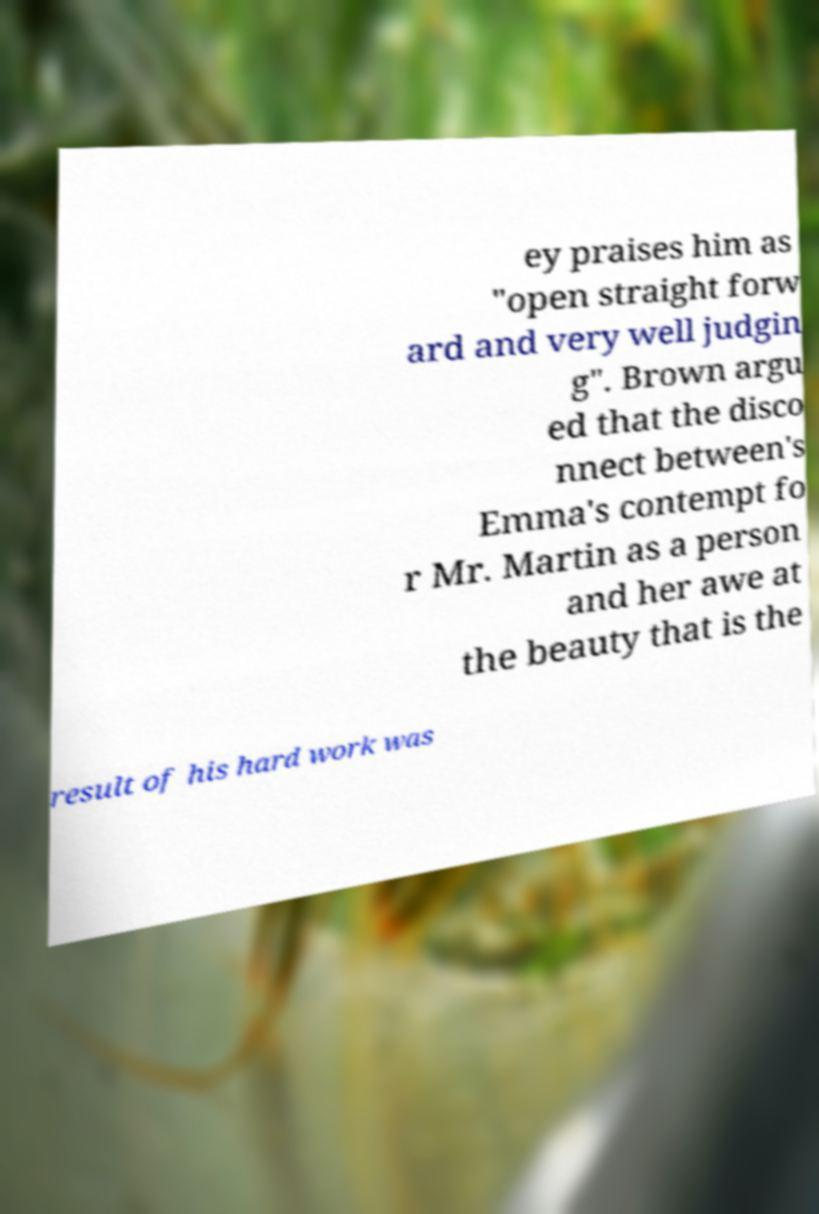I need the written content from this picture converted into text. Can you do that? ey praises him as "open straight forw ard and very well judgin g". Brown argu ed that the disco nnect between's Emma's contempt fo r Mr. Martin as a person and her awe at the beauty that is the result of his hard work was 